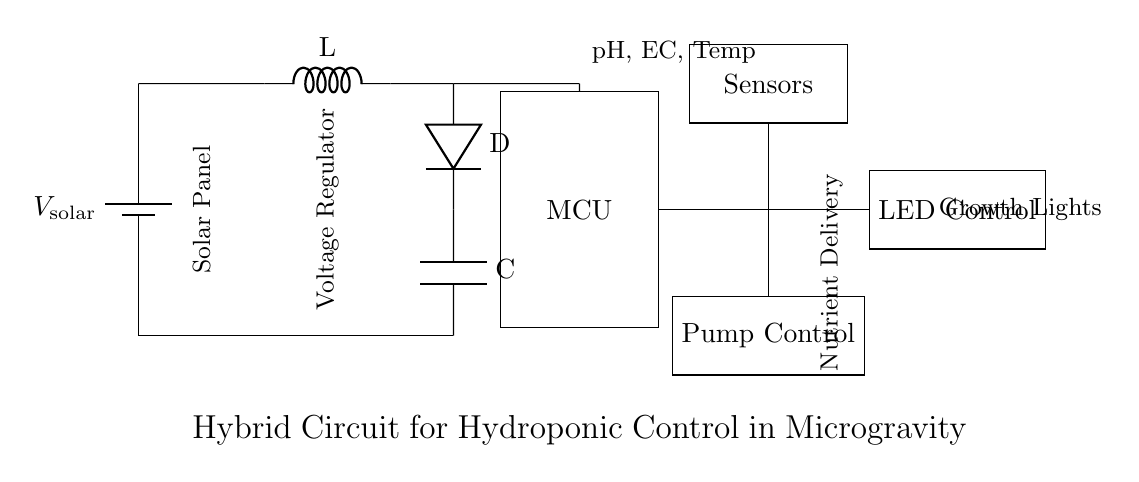What is the power source in this circuit? The power source is indicated at the beginning of the diagram and is a solar panel marked as V solar.
Answer: Solar panel What component regulates the voltage in the circuit? There is a voltage regulator symbol that appears after the solar panel and before the microcontroller, indicating it controls the voltage.
Answer: Voltage regulator What elements are connected to the microcontroller? The microcontroller connects to sensors, pump control, and LED control, as indicated by the lines drawn from it to these components.
Answer: Sensors, pump control, LED control How many types of control does this circuit manage? By examining the diagram, we see three control elements (pump, LED, and sensor control) connected to the microcontroller, which indicates the management types.
Answer: Three types What role does the inductor play in this circuit? The inductor is part of the voltage regulating section which helps in smoothing and filtering the voltage output from the solar panel to ensure stable operation for the microcontroller and other components.
Answer: Voltage regulation What is the function of the battery in this circuit? The battery acts as a buffer to store energy from the solar panel and supply a steady voltage to the other components, especially during periods of low solar energy.
Answer: Energy storage 